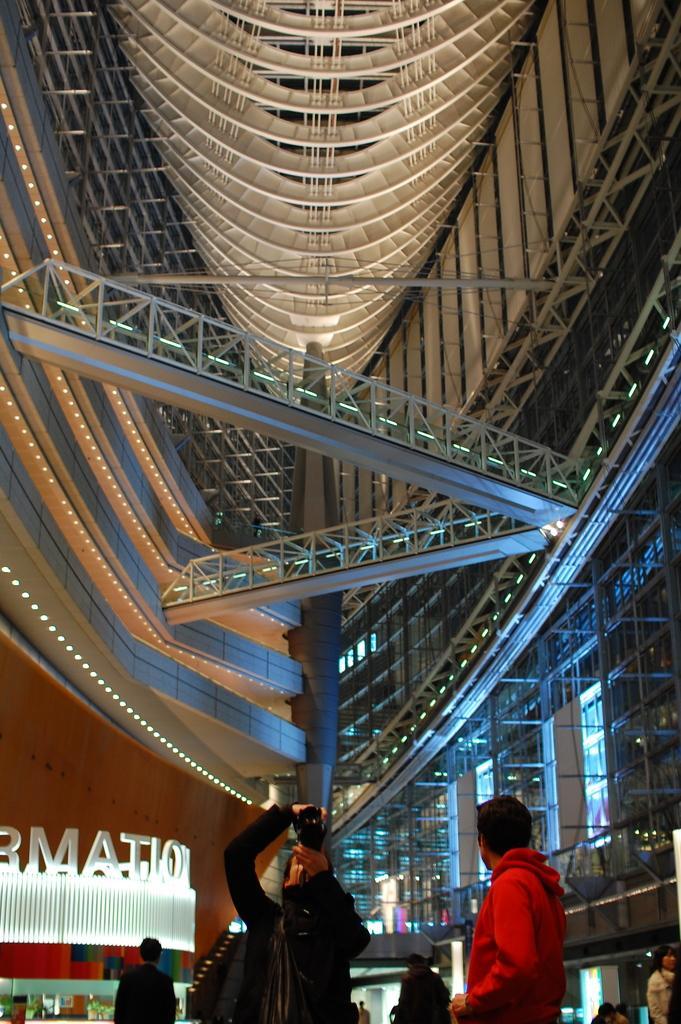Please provide a concise description of this image. At the bottom of the image there are few people. In front of the image there is a person holding an object in the hand. Behind them on the left side there is a store with a name. At the top of the image there is a ceiling with lights and also there are railings. 